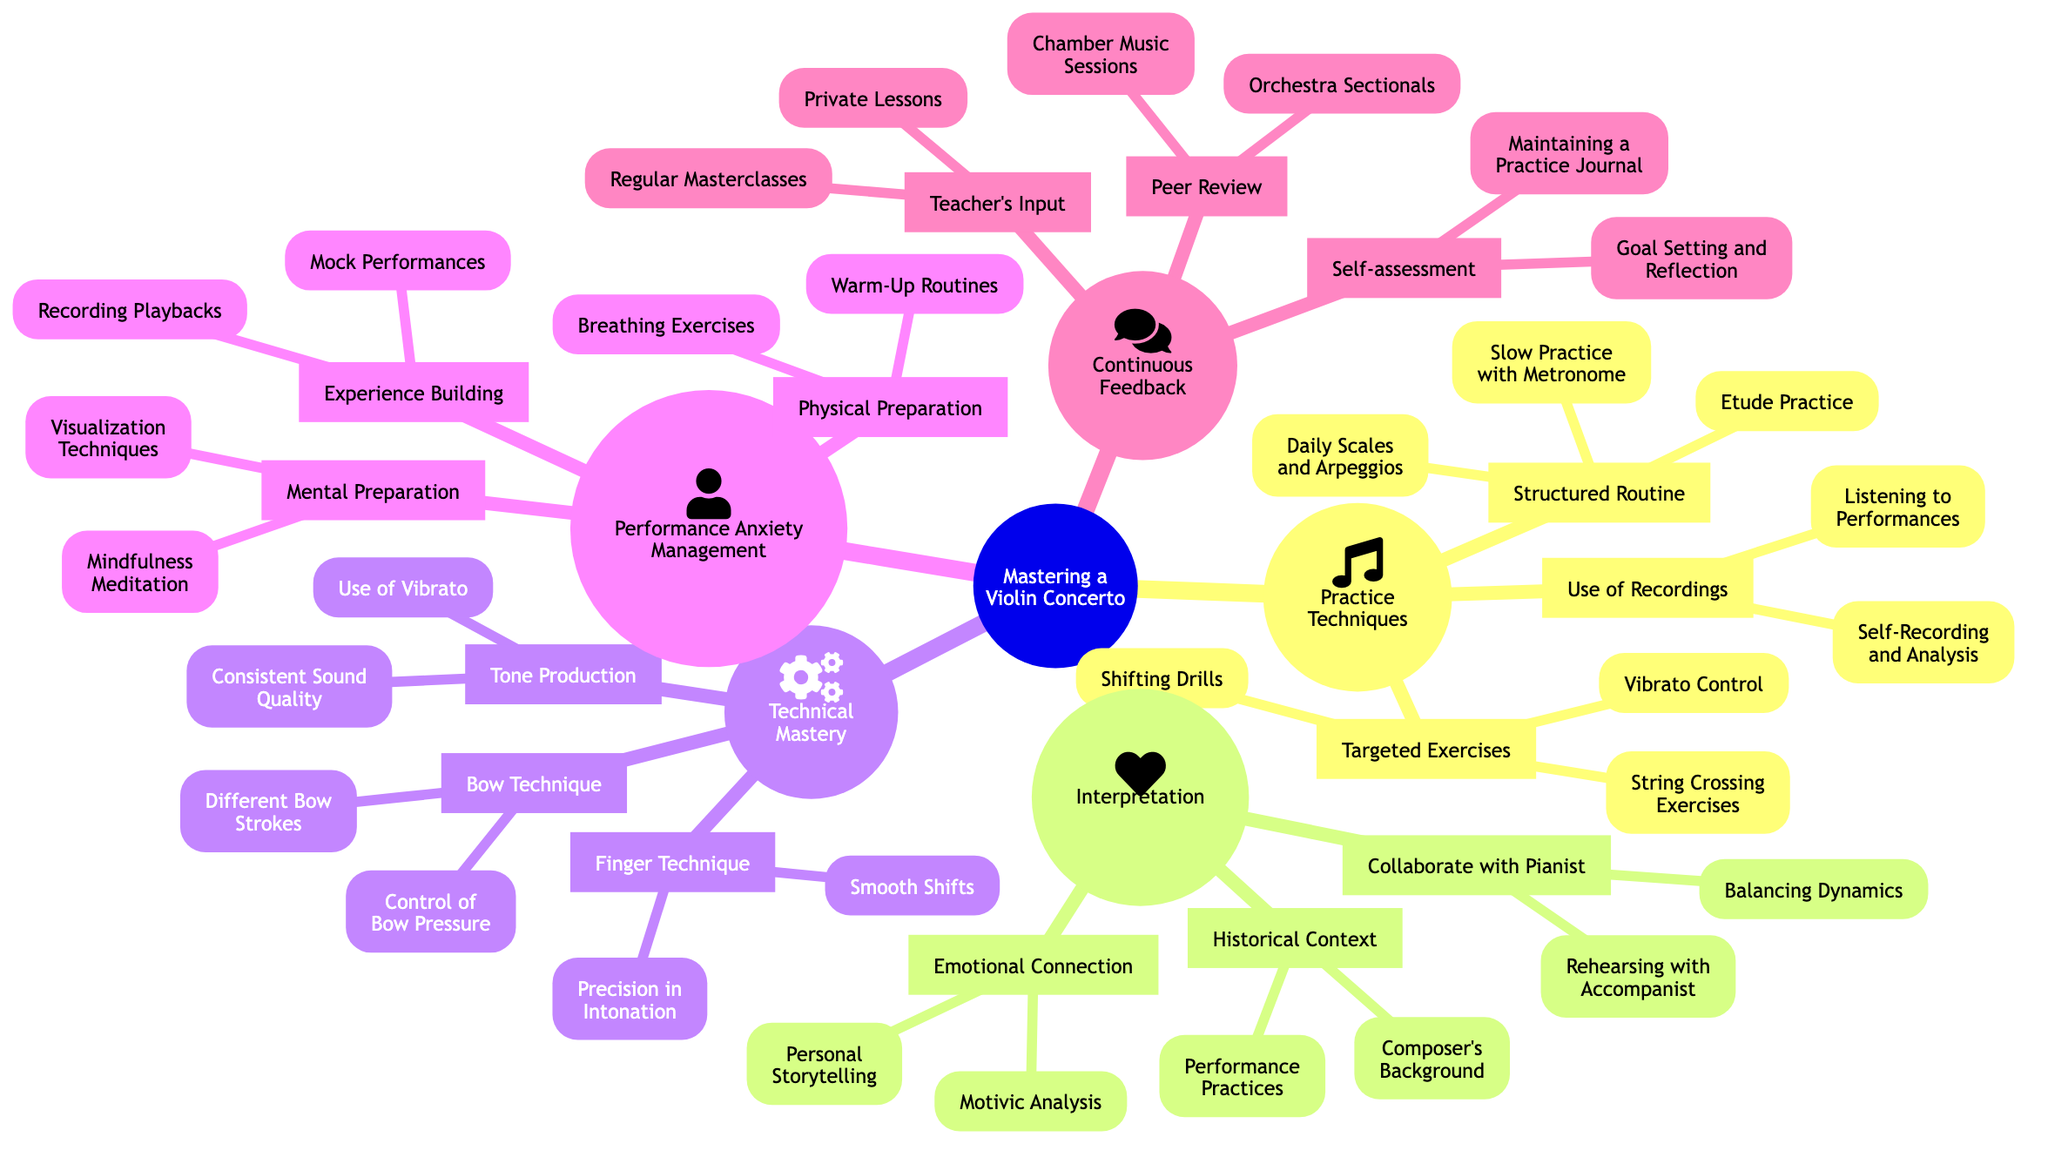What is one example of structured routine in practice techniques? In the "Practice Techniques" section, under "Structured Routine," one example listed is "Daily Scales and Arpeggios."
Answer: Daily Scales and Arpeggios How many categories are there under Technical Mastery? The "Technical Mastery" section has three categories: "Finger Technique," "Bow Technique," and "Tone Production." Thus, there are three categories in total.
Answer: 3 What are two types of mental preparation techniques mentioned for performance anxiety management? Under "Mental Preparation" in the "Performance Anxiety Management" section, "Visualization Techniques" and "Mindfulness Meditation" are both listed.
Answer: Visualization Techniques, Mindfulness Meditation Which section includes the concept of collaboratation with a pianist? The concept of collaboration with a pianist is found in the "Interpretation" section, specifically under the category "Collaborate with Pianist."
Answer: Interpretation What technique is used for building experience according to the diagram? In the "Performance Anxiety Management" section, under "Experience Building," one of the techniques is "Mock Performances."
Answer: Mock Performances Which area involves self-assessment and maintaining a journal? "Continuous Feedback" includes "Self-assessment," which contains maintaining a practice journal as a method.
Answer: Continuous Feedback What practice technique involves shifting drills and string crossing exercises? "Targeted Exercises" in the "Practice Techniques" section includes shifting drills and string crossing exercises as part of honing specific skills.
Answer: Targeted Exercises What is one main focus of the Emotional Connection category in interpretation? The "Emotional Connection" category in the "Interpretation" section focuses on "Personal Storytelling" as a key element.
Answer: Personal Storytelling 